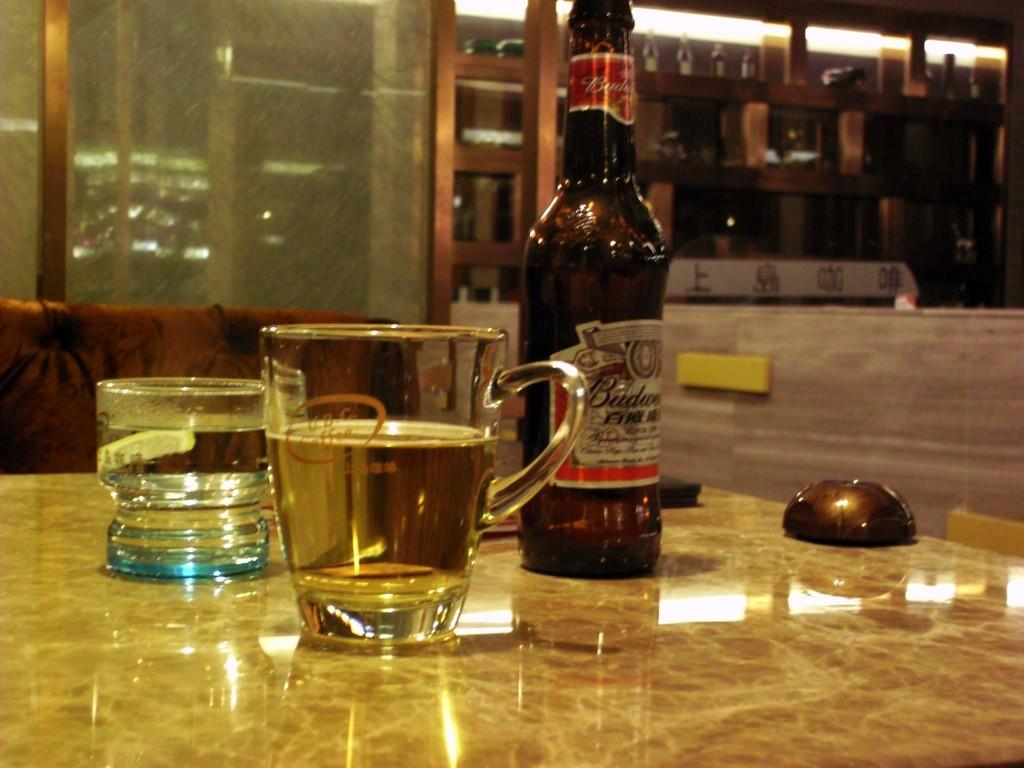<image>
Write a terse but informative summary of the picture. A bottle of Budweiser is on a table with two glasses. 